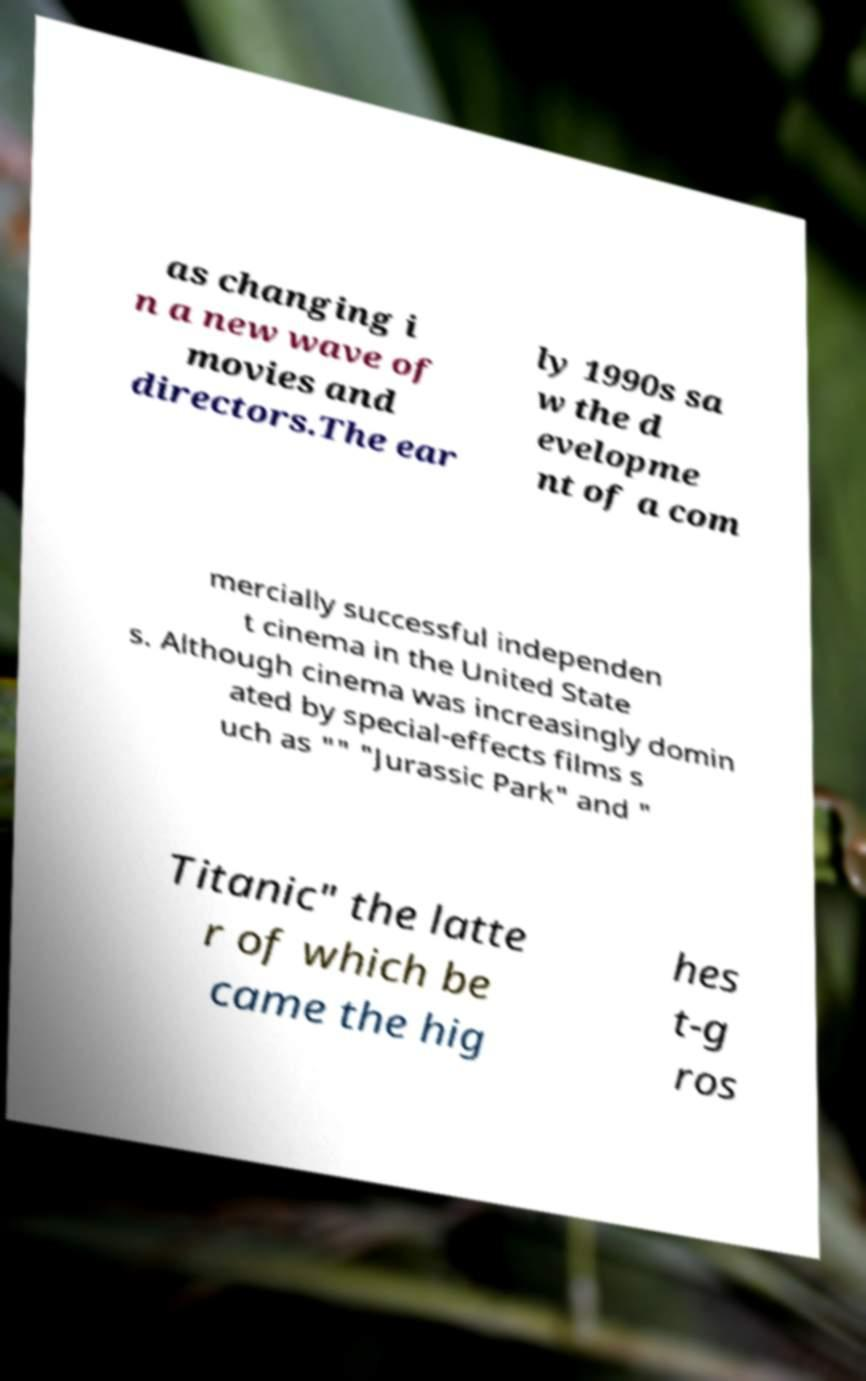Can you accurately transcribe the text from the provided image for me? as changing i n a new wave of movies and directors.The ear ly 1990s sa w the d evelopme nt of a com mercially successful independen t cinema in the United State s. Although cinema was increasingly domin ated by special-effects films s uch as "" "Jurassic Park" and " Titanic" the latte r of which be came the hig hes t-g ros 